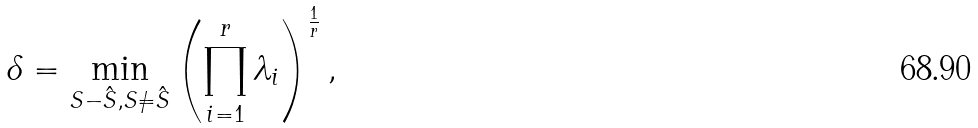Convert formula to latex. <formula><loc_0><loc_0><loc_500><loc_500>\delta = \min _ { S - \hat { S } , S \neq \hat { S } } \left ( \prod _ { i = 1 } ^ { r } \lambda _ { i } \right ) ^ { \frac { 1 } { r } } ,</formula> 